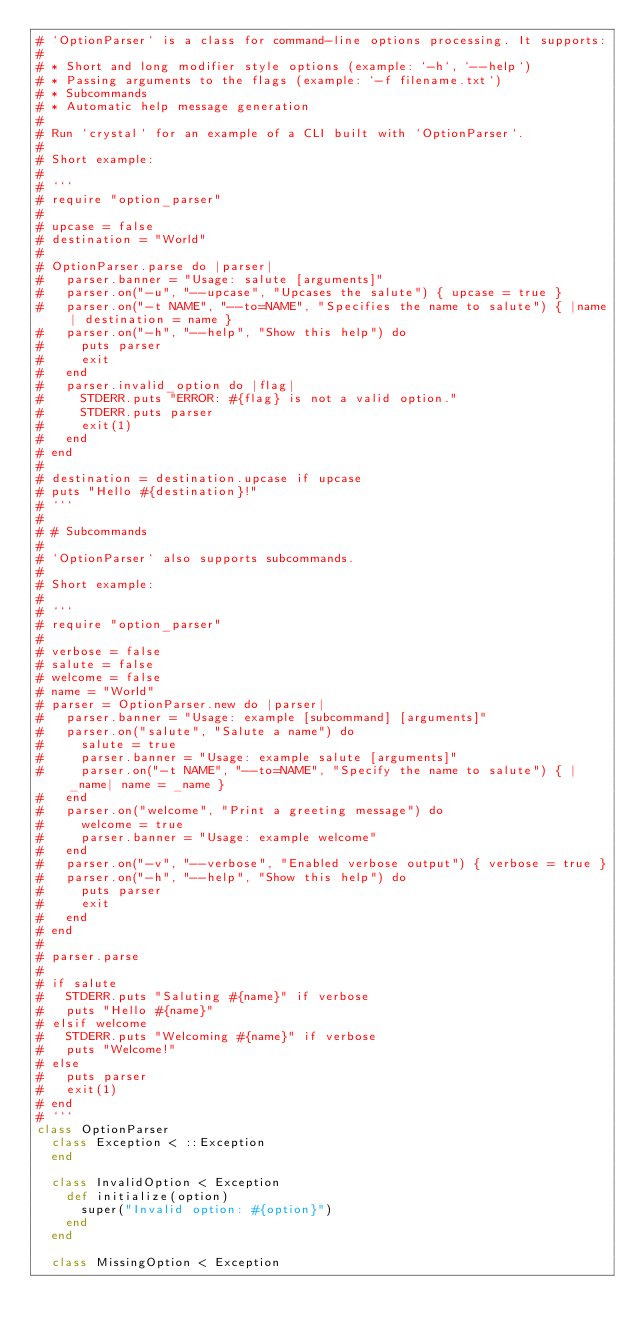Convert code to text. <code><loc_0><loc_0><loc_500><loc_500><_Crystal_># `OptionParser` is a class for command-line options processing. It supports:
#
# * Short and long modifier style options (example: `-h`, `--help`)
# * Passing arguments to the flags (example: `-f filename.txt`)
# * Subcommands
# * Automatic help message generation
#
# Run `crystal` for an example of a CLI built with `OptionParser`.
#
# Short example:
#
# ```
# require "option_parser"
#
# upcase = false
# destination = "World"
#
# OptionParser.parse do |parser|
#   parser.banner = "Usage: salute [arguments]"
#   parser.on("-u", "--upcase", "Upcases the salute") { upcase = true }
#   parser.on("-t NAME", "--to=NAME", "Specifies the name to salute") { |name| destination = name }
#   parser.on("-h", "--help", "Show this help") do
#     puts parser
#     exit
#   end
#   parser.invalid_option do |flag|
#     STDERR.puts "ERROR: #{flag} is not a valid option."
#     STDERR.puts parser
#     exit(1)
#   end
# end
#
# destination = destination.upcase if upcase
# puts "Hello #{destination}!"
# ```
#
# # Subcommands
#
# `OptionParser` also supports subcommands.
#
# Short example:
#
# ```
# require "option_parser"
#
# verbose = false
# salute = false
# welcome = false
# name = "World"
# parser = OptionParser.new do |parser|
#   parser.banner = "Usage: example [subcommand] [arguments]"
#   parser.on("salute", "Salute a name") do
#     salute = true
#     parser.banner = "Usage: example salute [arguments]"
#     parser.on("-t NAME", "--to=NAME", "Specify the name to salute") { |_name| name = _name }
#   end
#   parser.on("welcome", "Print a greeting message") do
#     welcome = true
#     parser.banner = "Usage: example welcome"
#   end
#   parser.on("-v", "--verbose", "Enabled verbose output") { verbose = true }
#   parser.on("-h", "--help", "Show this help") do
#     puts parser
#     exit
#   end
# end
#
# parser.parse
#
# if salute
#   STDERR.puts "Saluting #{name}" if verbose
#   puts "Hello #{name}"
# elsif welcome
#   STDERR.puts "Welcoming #{name}" if verbose
#   puts "Welcome!"
# else
#   puts parser
#   exit(1)
# end
# ```
class OptionParser
  class Exception < ::Exception
  end

  class InvalidOption < Exception
    def initialize(option)
      super("Invalid option: #{option}")
    end
  end

  class MissingOption < Exception</code> 